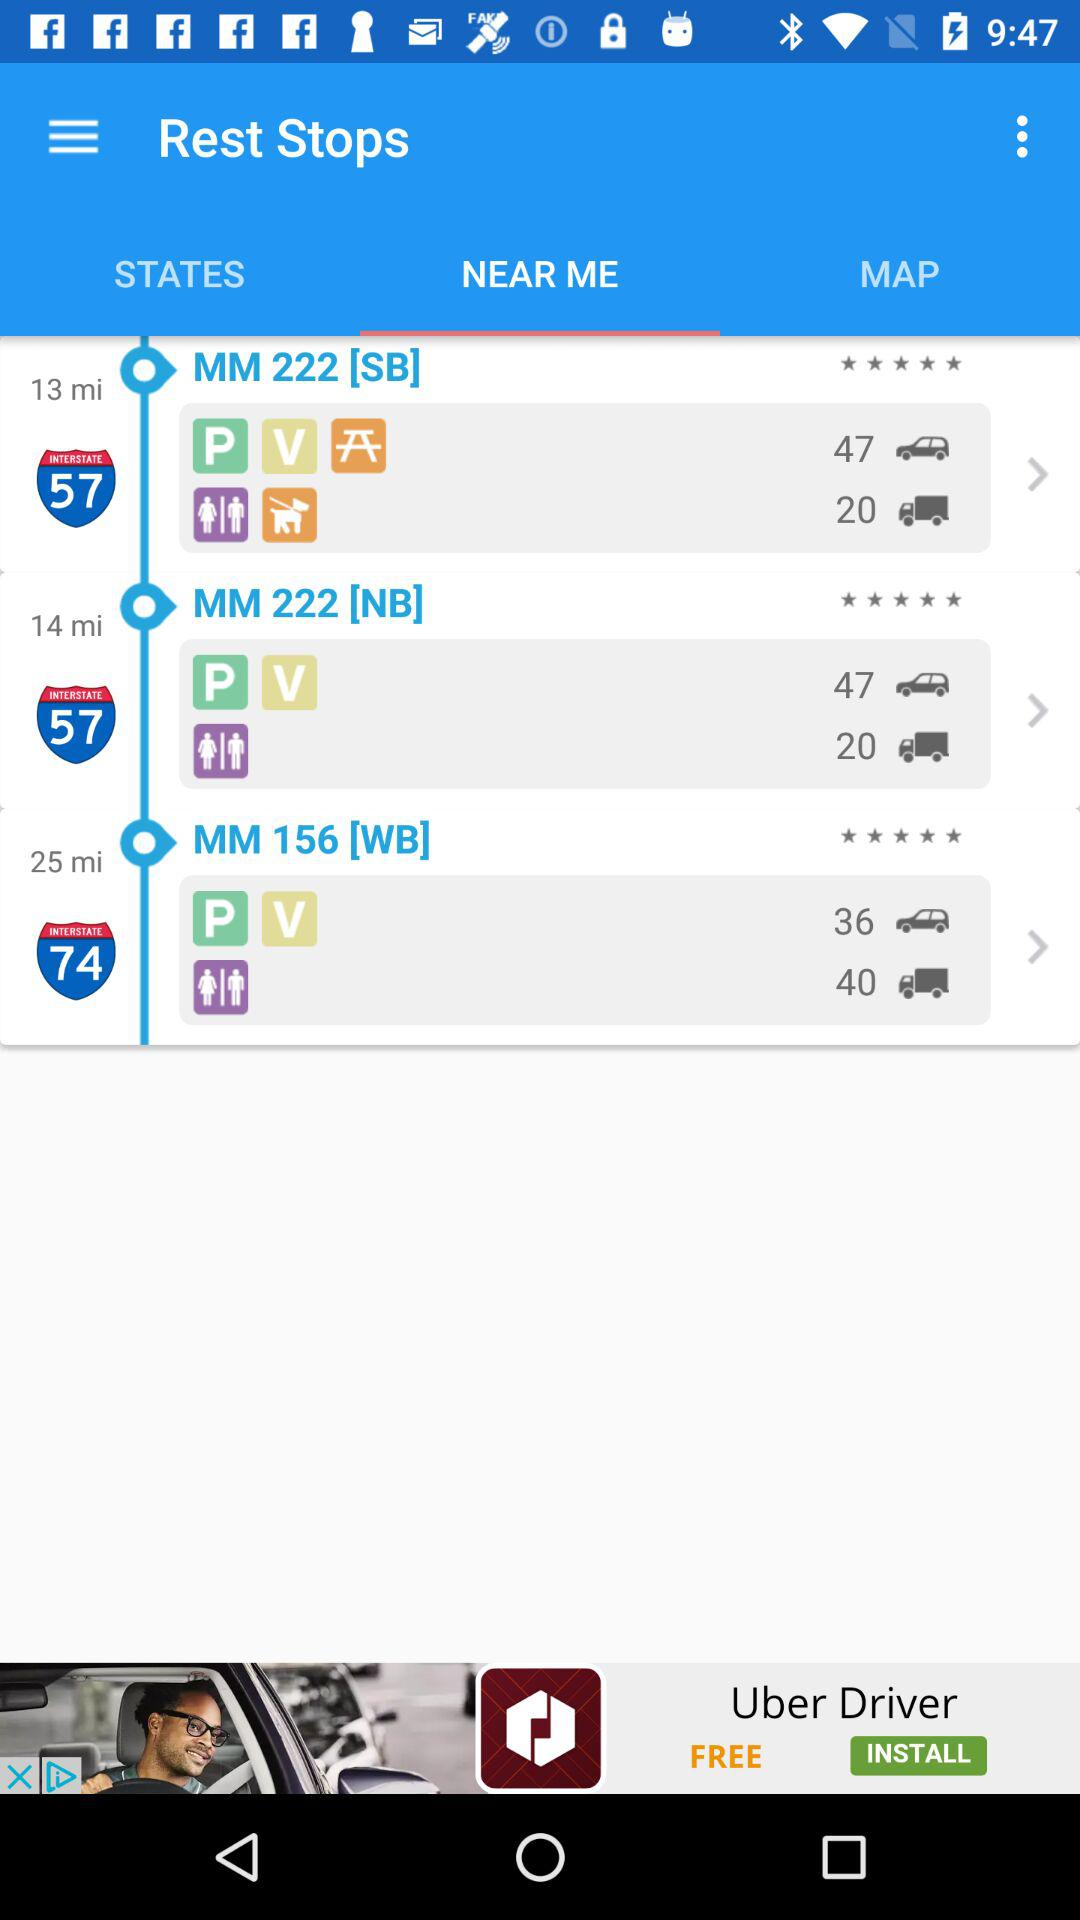What is the distance from my location to MM 222 [SB]? The distance is 13 miles. 